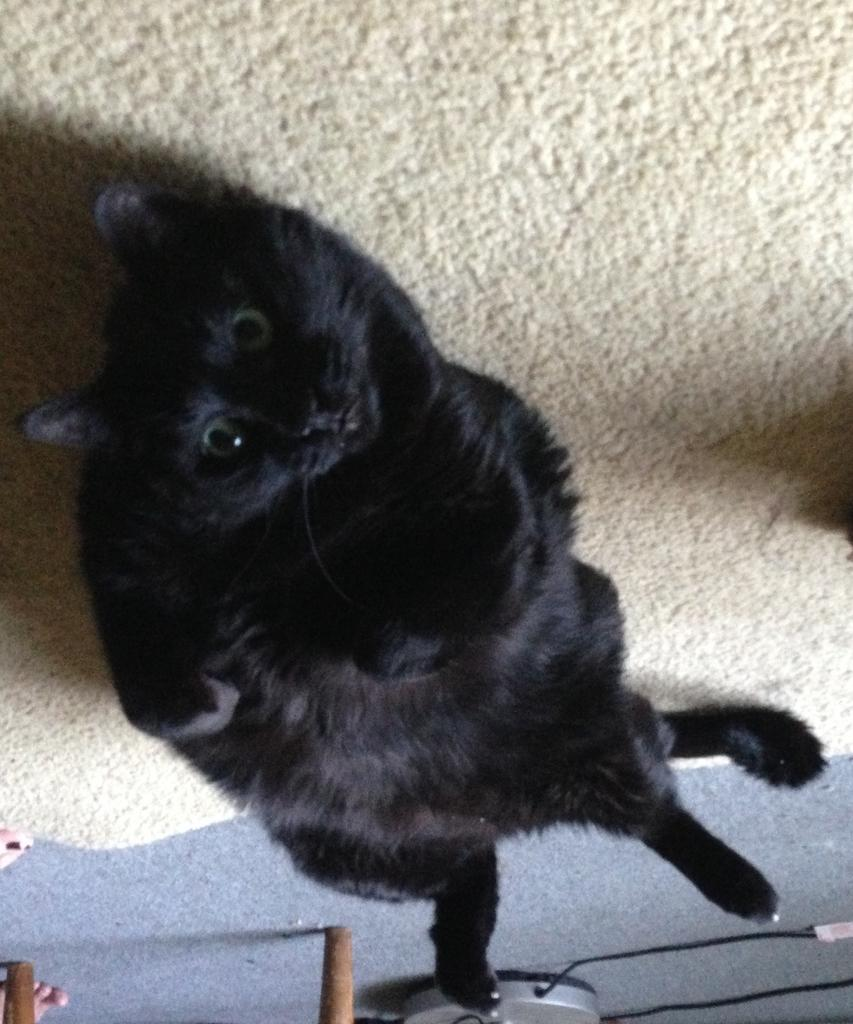What type of animal is in the image? There is a black cat in the image. What is the cat doing in the image? The cat is lying on the carpet. What is the cat's gaze directed towards in the image? The cat is looking at the camera. What is the price of the twig in the image? There is no twig present in the image, so it is not possible to determine its price. 